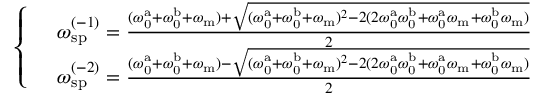<formula> <loc_0><loc_0><loc_500><loc_500>\begin{array} { r l } & { \left \{ \begin{array} { l l } & { \omega _ { s p } ^ { ( - 1 ) } = \frac { ( \omega _ { 0 } ^ { a } + \omega _ { 0 } ^ { b } + \omega _ { m } ) + \sqrt { ( \omega _ { 0 } ^ { a } + \omega _ { 0 } ^ { b } + \omega _ { m } ) ^ { 2 } - 2 ( 2 \omega _ { 0 } ^ { a } \omega _ { 0 } ^ { b } + \omega _ { 0 } ^ { a } \omega _ { m } + \omega _ { 0 } ^ { b } \omega _ { m } ) } } { 2 } } \\ & { \omega _ { s p } ^ { ( - 2 ) } = \frac { ( \omega _ { 0 } ^ { a } + \omega _ { 0 } ^ { b } + \omega _ { m } ) - \sqrt { ( \omega _ { 0 } ^ { a } + \omega _ { 0 } ^ { b } + \omega _ { m } ) ^ { 2 } - 2 ( 2 \omega _ { 0 } ^ { a } \omega _ { 0 } ^ { b } + \omega _ { 0 } ^ { a } \omega _ { m } + \omega _ { 0 } ^ { b } \omega _ { m } ) } } { 2 } } \end{array} } \end{array}</formula> 